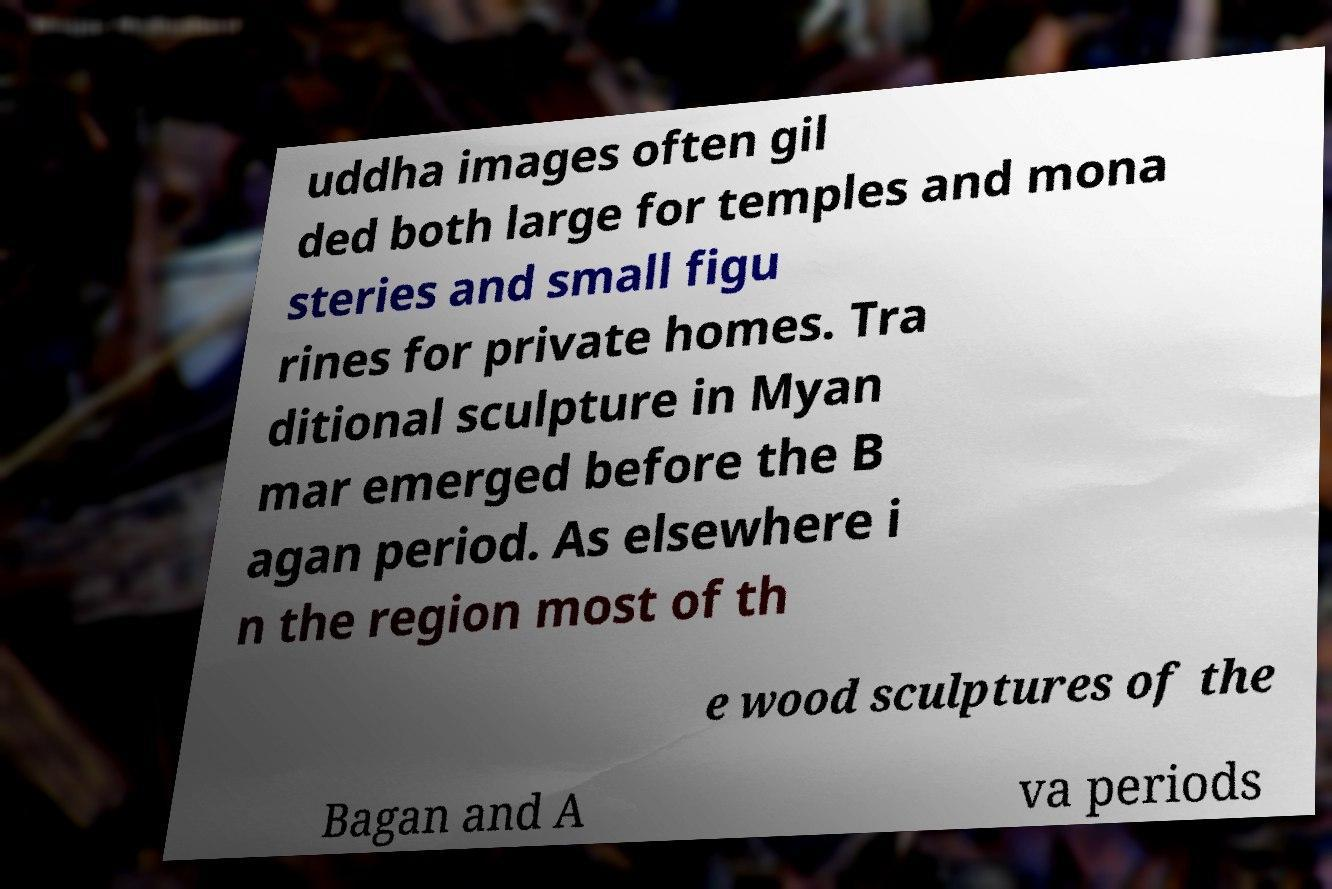Can you accurately transcribe the text from the provided image for me? uddha images often gil ded both large for temples and mona steries and small figu rines for private homes. Tra ditional sculpture in Myan mar emerged before the B agan period. As elsewhere i n the region most of th e wood sculptures of the Bagan and A va periods 